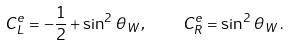<formula> <loc_0><loc_0><loc_500><loc_500>C _ { L } ^ { e } = - \frac { 1 } { 2 } + \sin ^ { 2 } \, \theta _ { W } \, , \quad C _ { R } ^ { e } = \sin ^ { 2 } \, \theta _ { W } \, .</formula> 